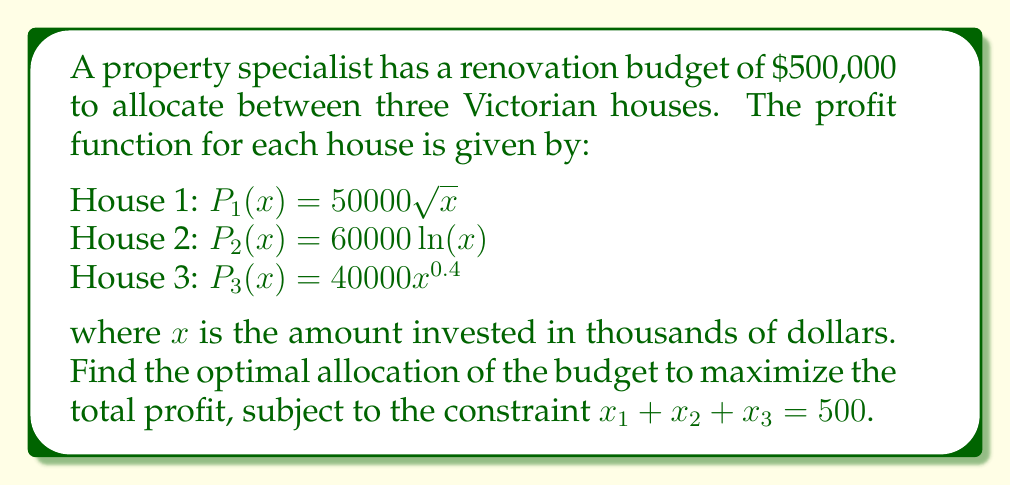Solve this math problem. To solve this constrained optimization problem, we'll use the method of Lagrange multipliers.

Step 1: Form the Lagrangian function
$$L(x_1, x_2, x_3, \lambda) = 50000\sqrt{x_1} + 60000\ln(x_2) + 40000x_3^{0.4} - \lambda(x_1 + x_2 + x_3 - 500)$$

Step 2: Take partial derivatives and set them equal to zero
$$\frac{\partial L}{\partial x_1} = \frac{25000}{\sqrt{x_1}} - \lambda = 0$$
$$\frac{\partial L}{\partial x_2} = \frac{60000}{x_2} - \lambda = 0$$
$$\frac{\partial L}{\partial x_3} = 16000x_3^{-0.6} - \lambda = 0$$
$$\frac{\partial L}{\partial \lambda} = x_1 + x_2 + x_3 - 500 = 0$$

Step 3: Solve the system of equations
From the first three equations:
$$x_1 = \left(\frac{25000}{\lambda}\right)^2$$
$$x_2 = \frac{60000}{\lambda}$$
$$x_3 = \left(\frac{16000}{\lambda}\right)^{5/3}$$

Substitute these into the constraint equation:
$$\left(\frac{25000}{\lambda}\right)^2 + \frac{60000}{\lambda} + \left(\frac{16000}{\lambda}\right)^{5/3} = 500$$

This equation can be solved numerically to find $\lambda \approx 239.4$.

Step 4: Calculate the optimal allocations
$$x_1 \approx 10900$$
$$x_2 \approx 250600$$
$$x_3 \approx 238500$$

Step 5: Convert to thousands of dollars
$$x_1 \approx 10.9$$
$$x_2 \approx 250.6$$
$$x_3 \approx 238.5$$
Answer: $x_1 \approx 10.9, x_2 \approx 250.6, x_3 \approx 238.5$ (in thousands of dollars) 